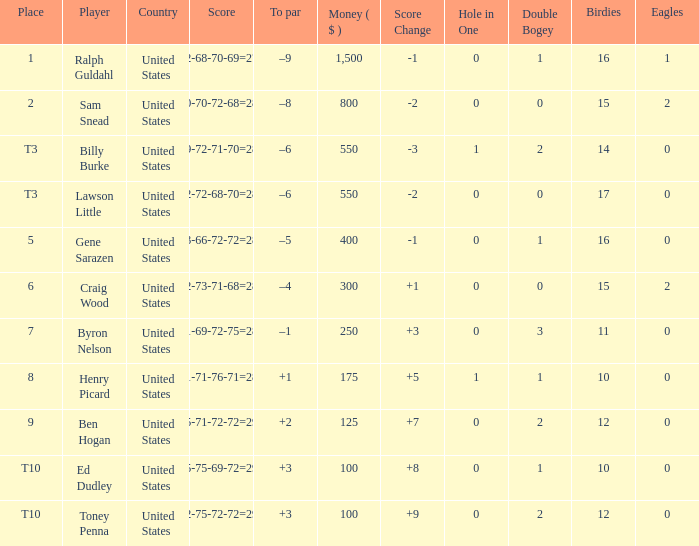Which score has a prize of $400? 73-66-72-72=283. 